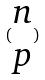<formula> <loc_0><loc_0><loc_500><loc_500>( \begin{matrix} n \\ p \end{matrix} )</formula> 